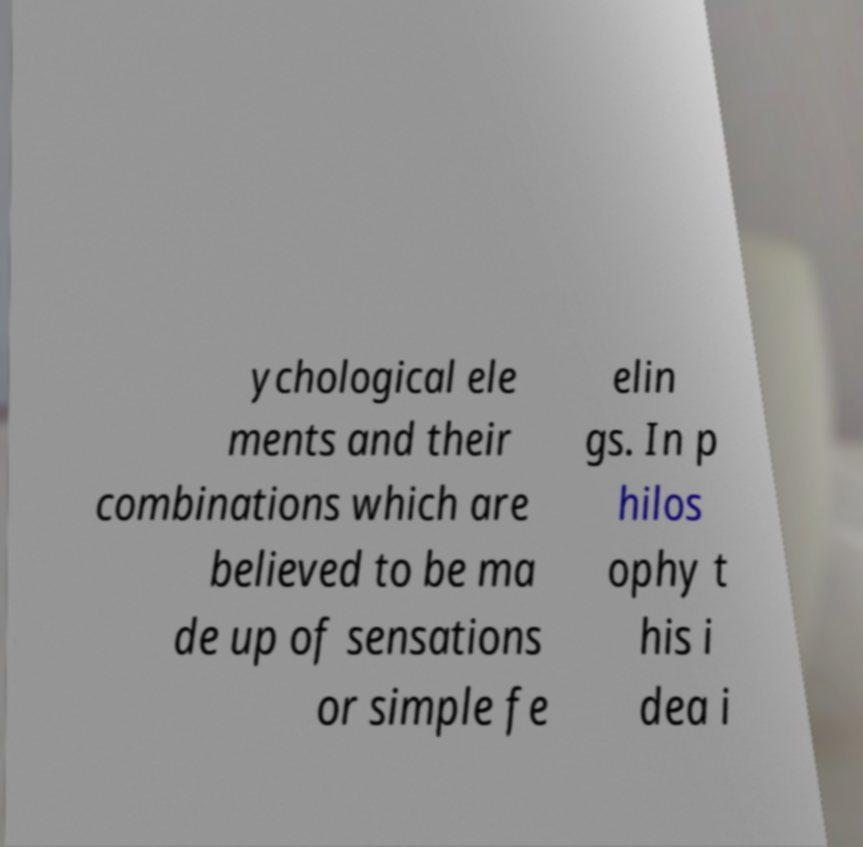For documentation purposes, I need the text within this image transcribed. Could you provide that? ychological ele ments and their combinations which are believed to be ma de up of sensations or simple fe elin gs. In p hilos ophy t his i dea i 